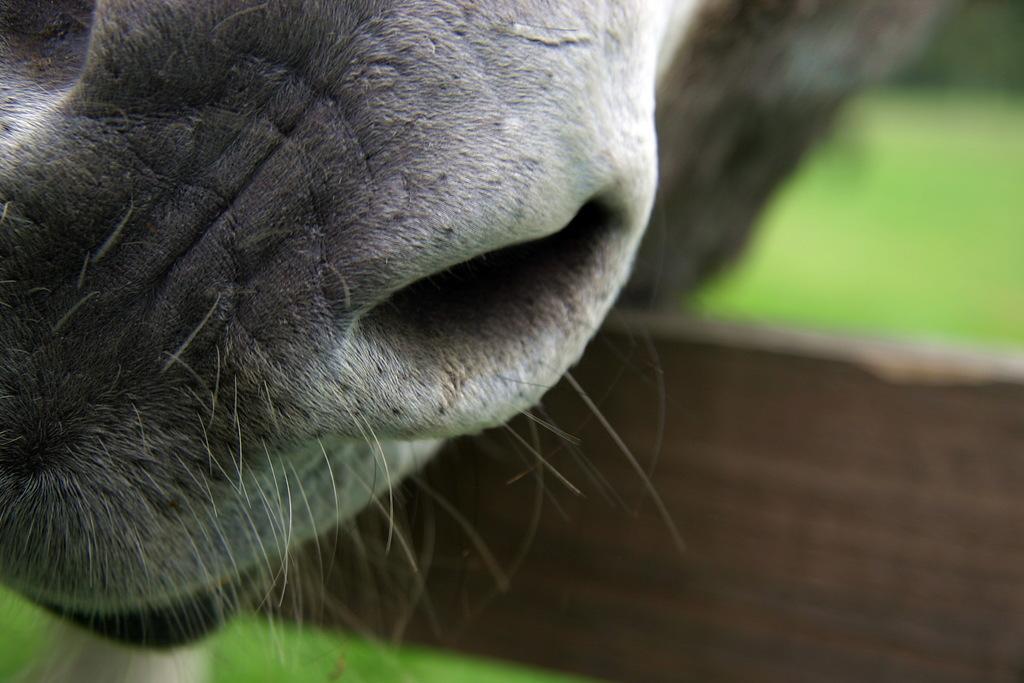Please provide a concise description of this image. In the image we can see a animal nose. Background of the image is blur. 